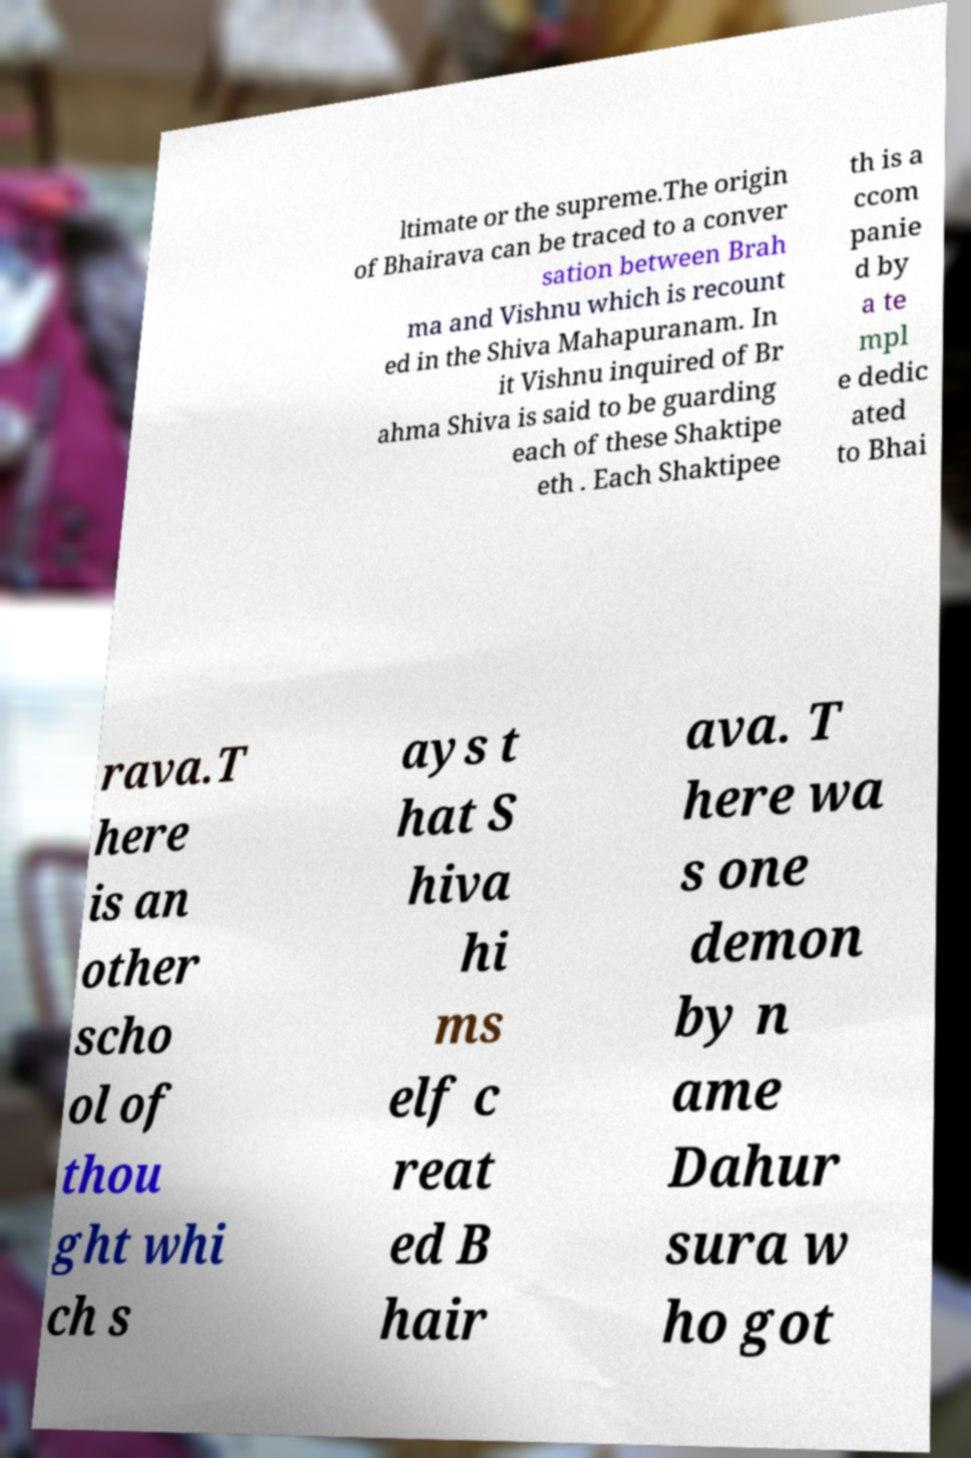Could you assist in decoding the text presented in this image and type it out clearly? ltimate or the supreme.The origin of Bhairava can be traced to a conver sation between Brah ma and Vishnu which is recount ed in the Shiva Mahapuranam. In it Vishnu inquired of Br ahma Shiva is said to be guarding each of these Shaktipe eth . Each Shaktipee th is a ccom panie d by a te mpl e dedic ated to Bhai rava.T here is an other scho ol of thou ght whi ch s ays t hat S hiva hi ms elf c reat ed B hair ava. T here wa s one demon by n ame Dahur sura w ho got 